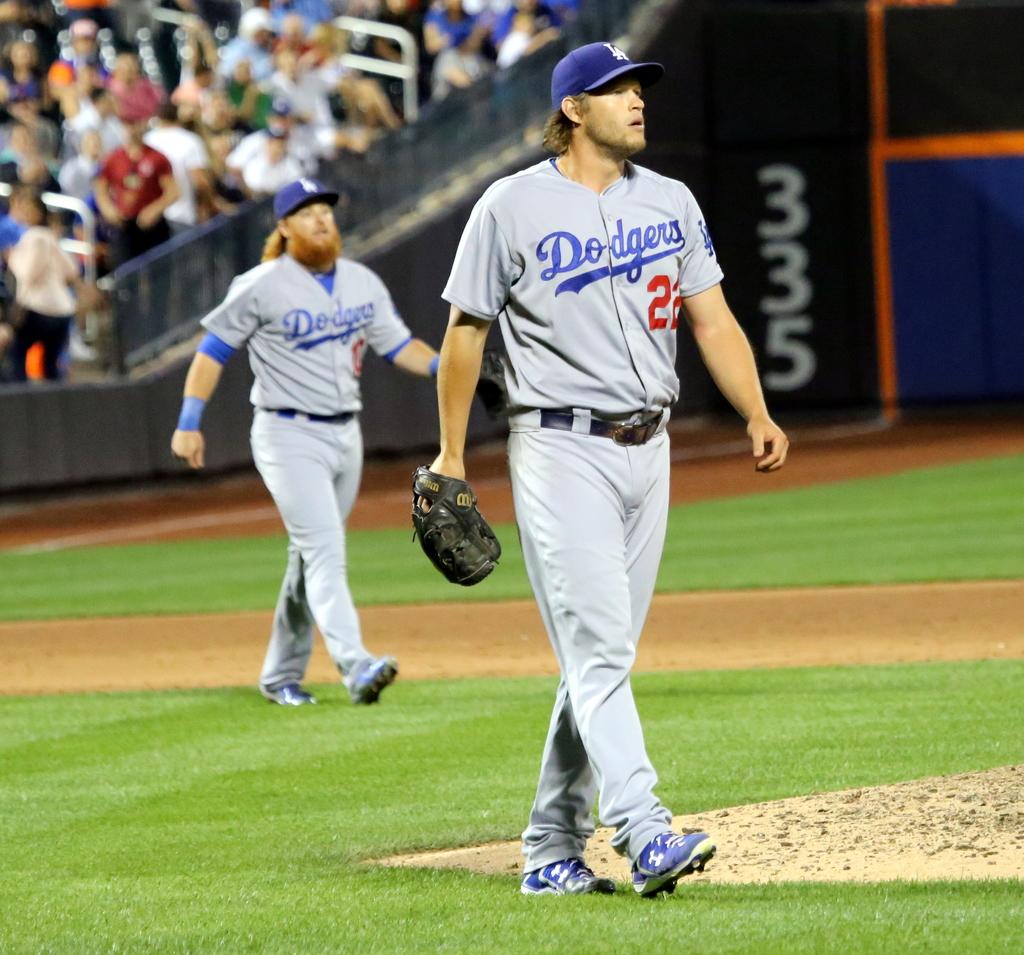What is the name of the baseball team playing in the photo?
Ensure brevity in your answer.  Dodgers. What numbers are in white on the back wall?
Keep it short and to the point. 335. 